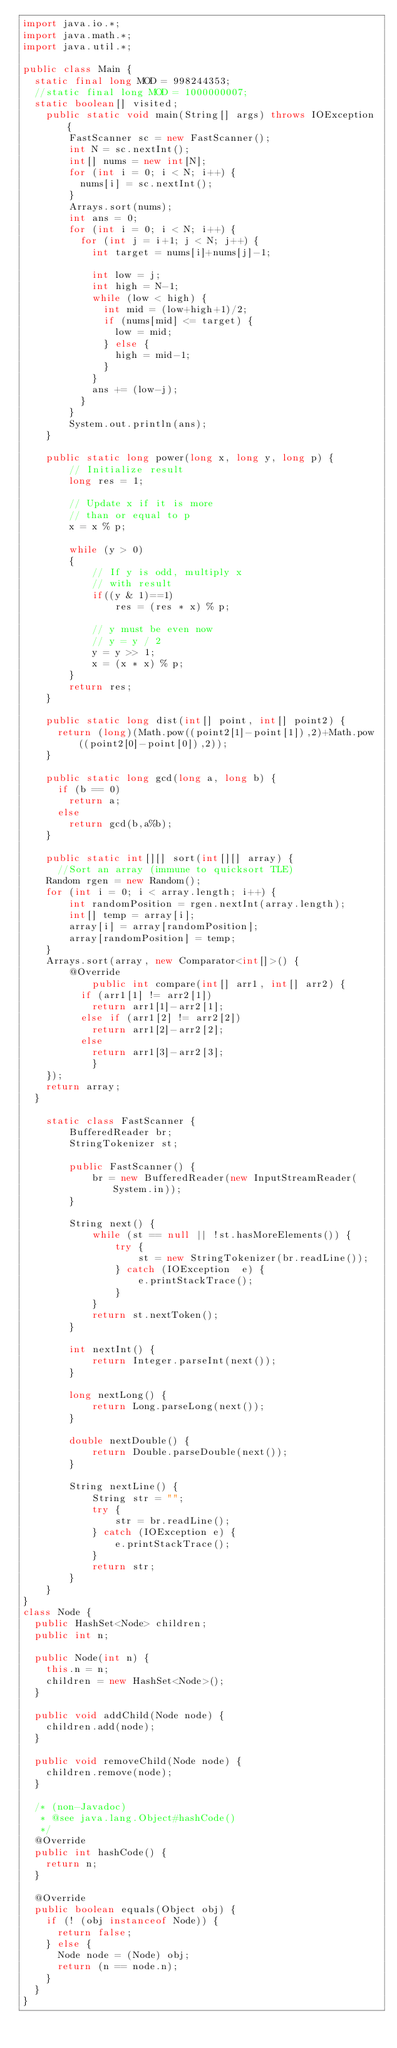<code> <loc_0><loc_0><loc_500><loc_500><_Java_>import java.io.*; 
import java.math.*;
import java.util.*;
 
public class Main {
	static final long MOD = 998244353;
	//static final long MOD = 1000000007;
	static boolean[] visited;
    public static void main(String[] args) throws IOException {
        FastScanner sc = new FastScanner();
        int N = sc.nextInt();
        int[] nums = new int[N];
        for (int i = 0; i < N; i++) {
        	nums[i] = sc.nextInt();
        }
        Arrays.sort(nums);
        int ans = 0;
        for (int i = 0; i < N; i++) {
        	for (int j = i+1; j < N; j++) {
        		int target = nums[i]+nums[j]-1;
        		
        		int low = j;
        		int high = N-1;
        		while (low < high) {
        			int mid = (low+high+1)/2;
        			if (nums[mid] <= target) {
        				low = mid;
        			} else {
        				high = mid-1;
        			}
        		}
        		ans += (low-j);
        	}
        }
        System.out.println(ans);
    }
    
    public static long power(long x, long y, long p) { 
        // Initialize result
        long res = 1;
         
        // Update x if it is more   
        // than or equal to p 
        x = x % p;  
      
        while (y > 0) 
        { 
            // If y is odd, multiply x 
            // with result 
            if((y & 1)==1) 
                res = (res * x) % p; 
      
            // y must be even now 
            // y = y / 2 
            y = y >> 1;  
            x = (x * x) % p;  
        } 
        return res; 
    }
    
    public static long dist(int[] point, int[] point2) {
    	return (long)(Math.pow((point2[1]-point[1]),2)+Math.pow((point2[0]-point[0]),2));
    }
    
    public static long gcd(long a, long b) {
    	if (b == 0)
    		return a;
    	else
    		return gcd(b,a%b);
    }
    
    public static int[][] sort(int[][] array) {
    	//Sort an array (immune to quicksort TLE)
		Random rgen = new Random();
		for (int i = 0; i < array.length; i++) {
		    int randomPosition = rgen.nextInt(array.length);
		    int[] temp = array[i];
		    array[i] = array[randomPosition];
		    array[randomPosition] = temp;
		}
		Arrays.sort(array, new Comparator<int[]>() {
			  @Override
        	  public int compare(int[] arr1, int[] arr2) {
				  if (arr1[1] != arr2[1])
					  return arr1[1]-arr2[1];
				  else if (arr1[2] != arr2[2])
					  return arr1[2]-arr2[2];
				  else
					  return arr1[3]-arr2[3];
	          }
		});
		return array;
	}
    
    static class FastScanner { 
        BufferedReader br; 
        StringTokenizer st; 
  
        public FastScanner() { 
            br = new BufferedReader(new InputStreamReader(System.in)); 
        } 
  
        String next() { 
            while (st == null || !st.hasMoreElements()) { 
                try { 
                    st = new StringTokenizer(br.readLine());
                } catch (IOException  e) { 
                    e.printStackTrace(); 
                } 
            } 
            return st.nextToken(); 
        } 
  
        int nextInt() { 
            return Integer.parseInt(next()); 
        } 
  
        long nextLong() { 
            return Long.parseLong(next()); 
        } 
  
        double nextDouble() { 
            return Double.parseDouble(next()); 
        } 
  
        String nextLine() { 
            String str = ""; 
            try { 
                str = br.readLine(); 
            } catch (IOException e) {
                e.printStackTrace(); 
            } 
            return str; 
        }
    }
}
class Node {
	public HashSet<Node> children;
	public int n;
	
	public Node(int n) {
		this.n = n;
		children = new HashSet<Node>();
	}
	
	public void addChild(Node node) {
		children.add(node);
	}
	
	public void removeChild(Node node) {
		children.remove(node);
	}

	/* (non-Javadoc)
	 * @see java.lang.Object#hashCode()
	 */
	@Override
	public int hashCode() {
		return n;
	}

	@Override
	public boolean equals(Object obj) {
		if (! (obj instanceof Node)) {
			return false;
		} else {
			Node node = (Node) obj;
			return (n == node.n);
		}
	}
}</code> 